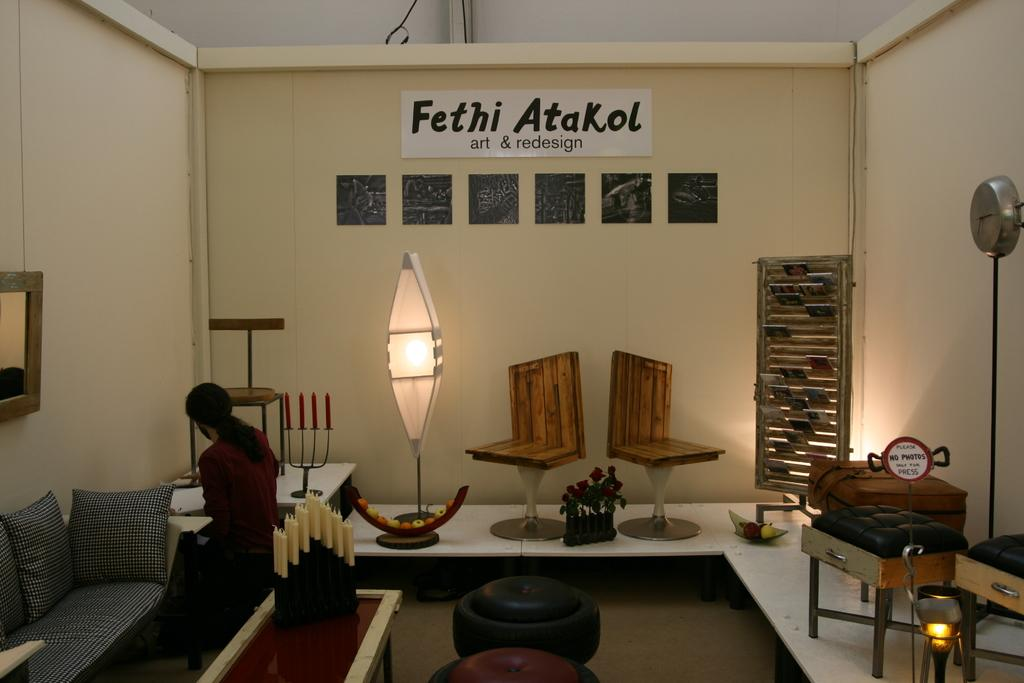<image>
Relay a brief, clear account of the picture shown. a furniture shop with a sign that reads Fethi Atakol on it 